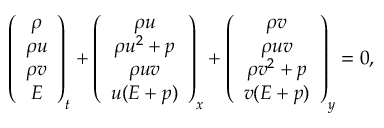Convert formula to latex. <formula><loc_0><loc_0><loc_500><loc_500>\left ( \begin{array} { c } { \rho } \\ { \rho u } \\ { \rho v } \\ { E } \end{array} \right ) _ { t } + \left ( \begin{array} { c } { \rho u } \\ { \rho u ^ { 2 } + p } \\ { \rho u v } \\ { u ( E + p ) } \end{array} \right ) _ { x } + \left ( \begin{array} { c } { \rho v } \\ { \rho u v } \\ { \rho v ^ { 2 } + p } \\ { v ( E + p ) } \end{array} \right ) _ { y } = 0 ,</formula> 